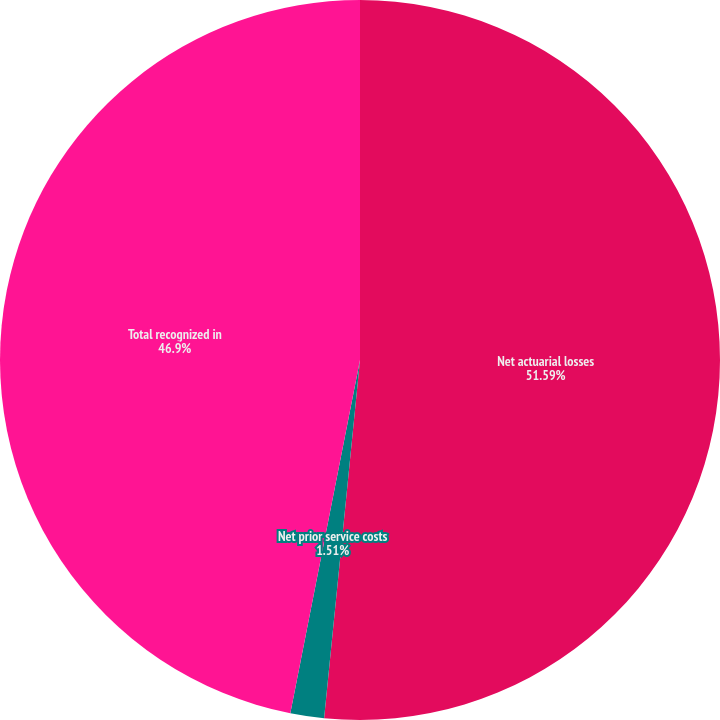Convert chart. <chart><loc_0><loc_0><loc_500><loc_500><pie_chart><fcel>Net actuarial losses<fcel>Net prior service costs<fcel>Total recognized in<nl><fcel>51.59%<fcel>1.51%<fcel>46.9%<nl></chart> 